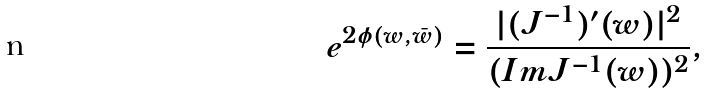<formula> <loc_0><loc_0><loc_500><loc_500>e ^ { 2 \phi ( w , \bar { w } ) } = { \frac { | ( J ^ { - 1 } ) ^ { \prime } ( w ) | ^ { 2 } } { ( I m J ^ { - 1 } ( w ) ) ^ { 2 } } } ,</formula> 